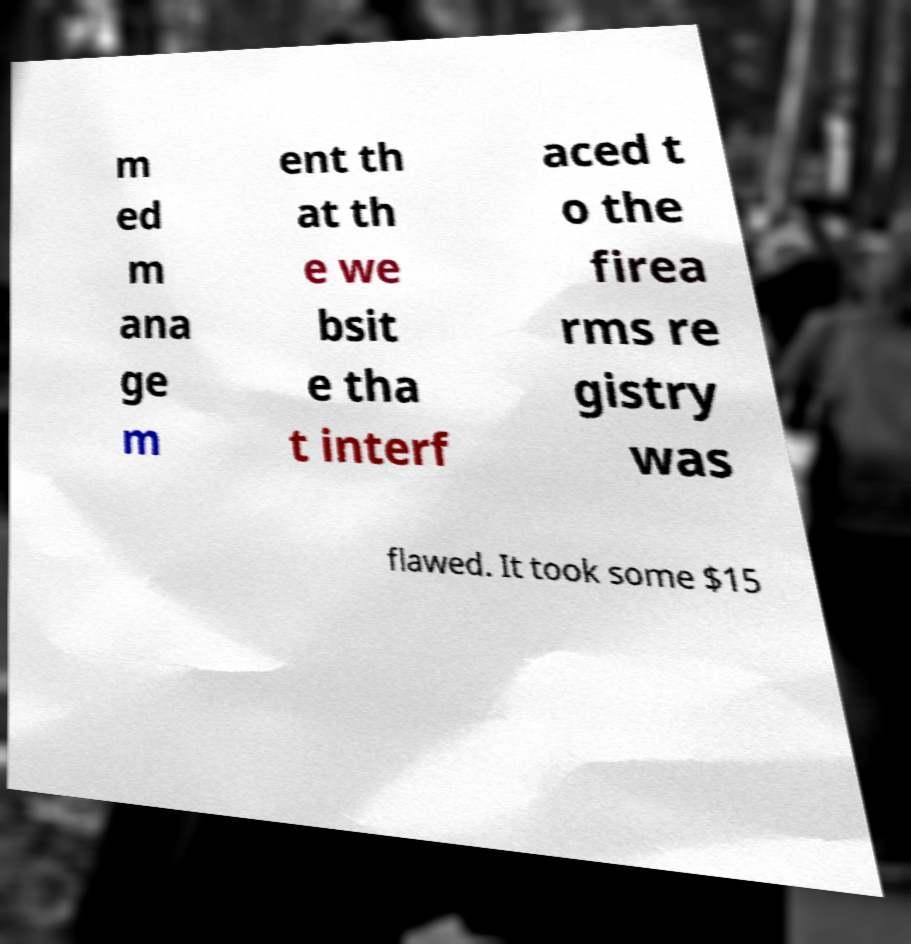What messages or text are displayed in this image? I need them in a readable, typed format. m ed m ana ge m ent th at th e we bsit e tha t interf aced t o the firea rms re gistry was flawed. It took some $15 